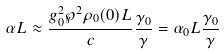<formula> <loc_0><loc_0><loc_500><loc_500>\alpha L \approx \frac { g _ { 0 } ^ { 2 } \wp ^ { 2 } \rho _ { 0 } ( 0 ) L } { c } \frac { \gamma _ { 0 } } { \gamma } = \alpha _ { 0 } L \frac { \gamma _ { 0 } } { \gamma }</formula> 